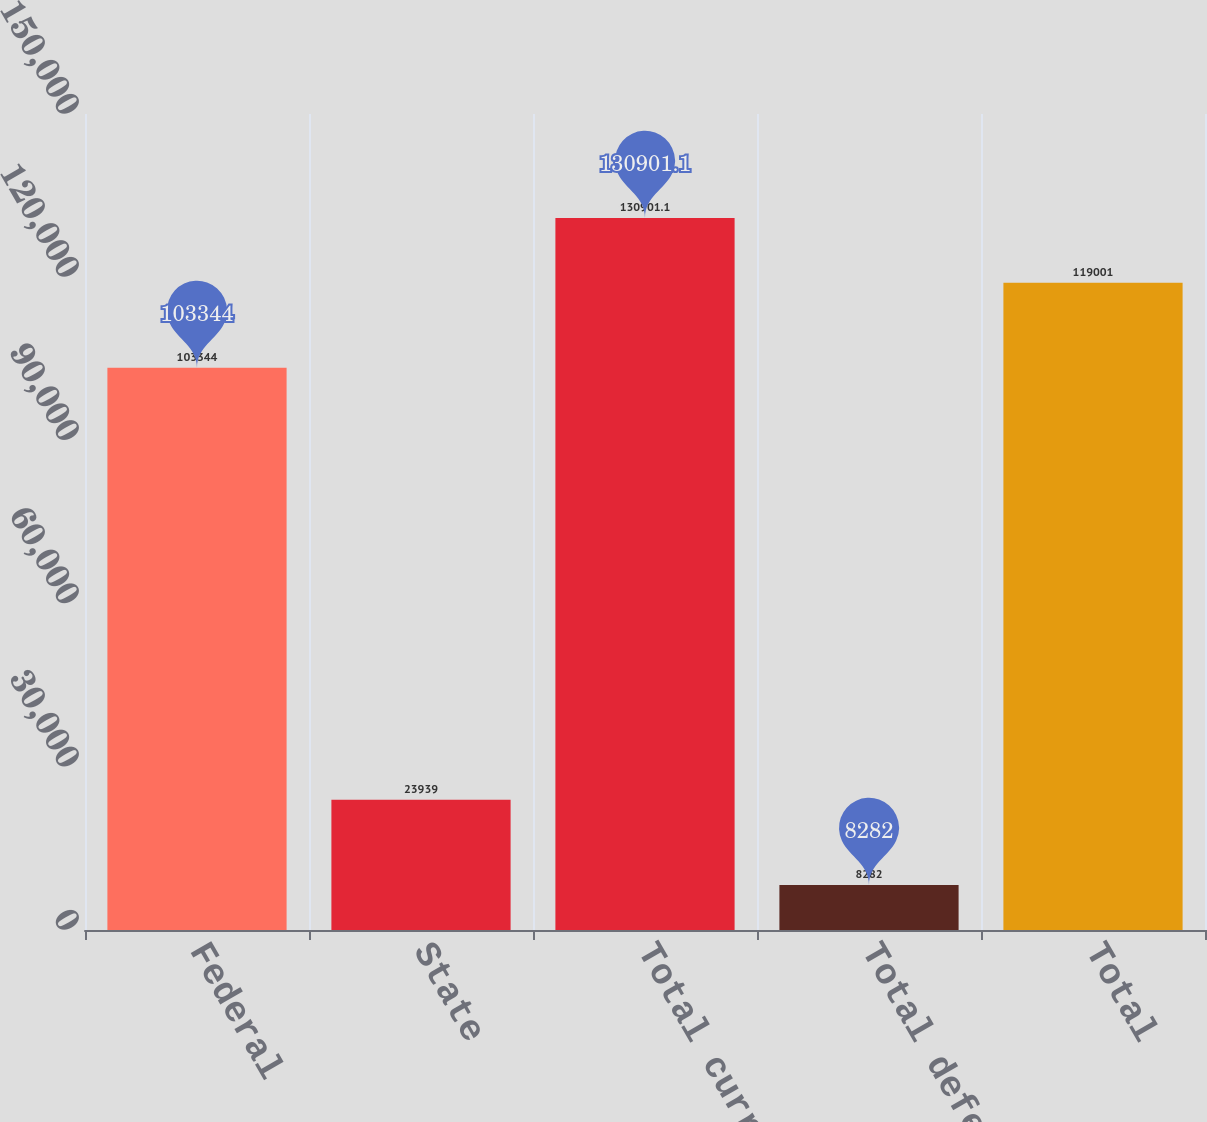Convert chart. <chart><loc_0><loc_0><loc_500><loc_500><bar_chart><fcel>Federal<fcel>State<fcel>Total current<fcel>Total deferred<fcel>Total<nl><fcel>103344<fcel>23939<fcel>130901<fcel>8282<fcel>119001<nl></chart> 